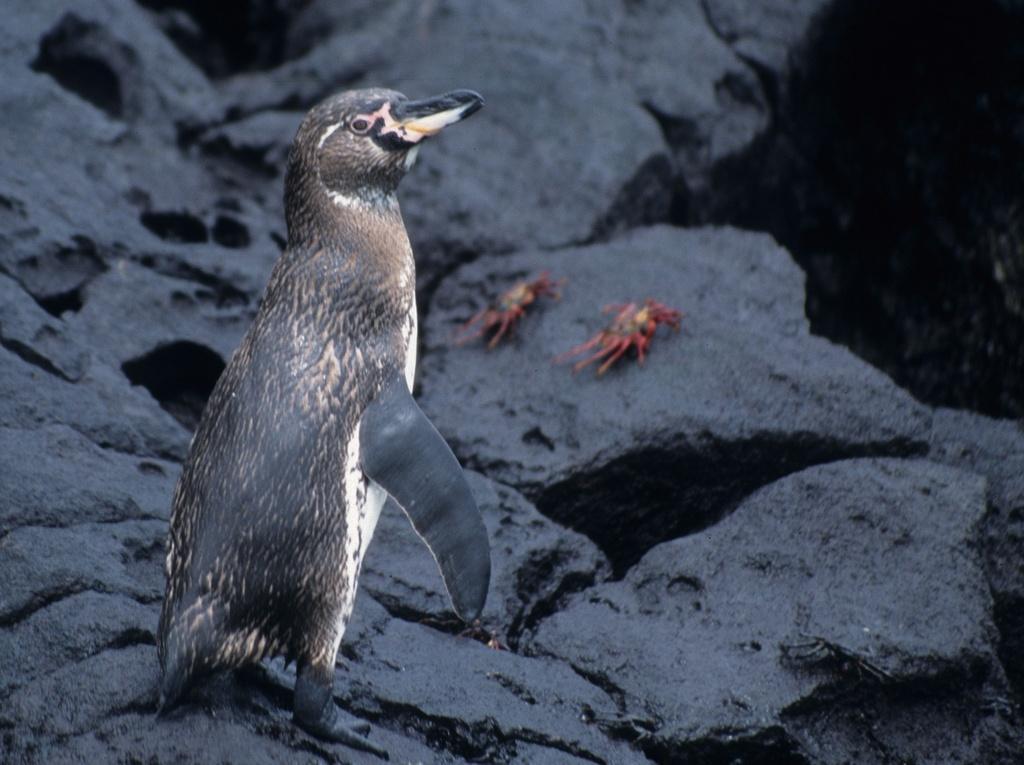Describe this image in one or two sentences. In this picture I can see a penguin standing in front and in the background I can see 2 crows and I see that it is a bit blurry in the background. 